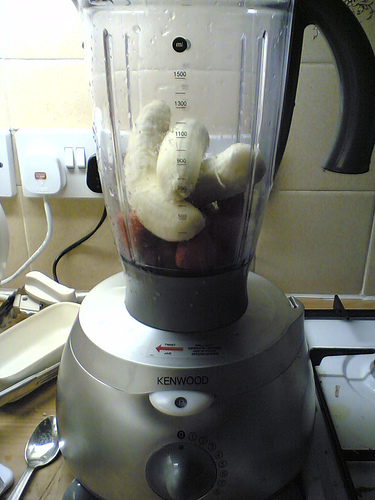Identify the text contained in this image. KENWOOD 1100 1300 1500 900 